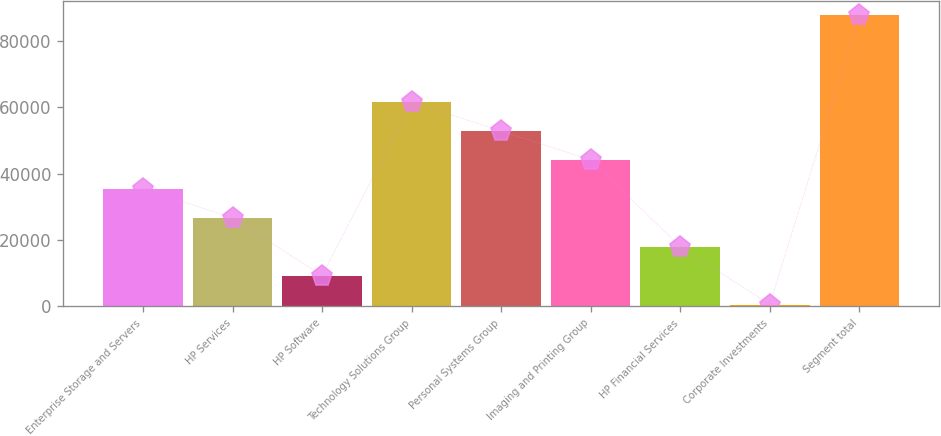Convert chart to OTSL. <chart><loc_0><loc_0><loc_500><loc_500><bar_chart><fcel>Enterprise Storage and Servers<fcel>HP Services<fcel>HP Software<fcel>Technology Solutions Group<fcel>Personal Systems Group<fcel>Imaging and Printing Group<fcel>HP Financial Services<fcel>Corporate Investments<fcel>Segment total<nl><fcel>35447.8<fcel>26716.6<fcel>9254.2<fcel>61641.4<fcel>52910.2<fcel>44179<fcel>17985.4<fcel>523<fcel>87835<nl></chart> 